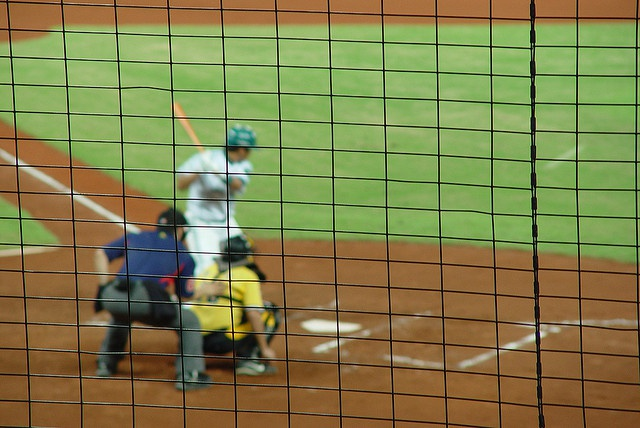Describe the objects in this image and their specific colors. I can see people in brown, black, gray, blue, and navy tones, people in brown, black, khaki, tan, and olive tones, people in brown, lightgray, lightblue, darkgray, and gray tones, and baseball bat in brown, tan, and khaki tones in this image. 